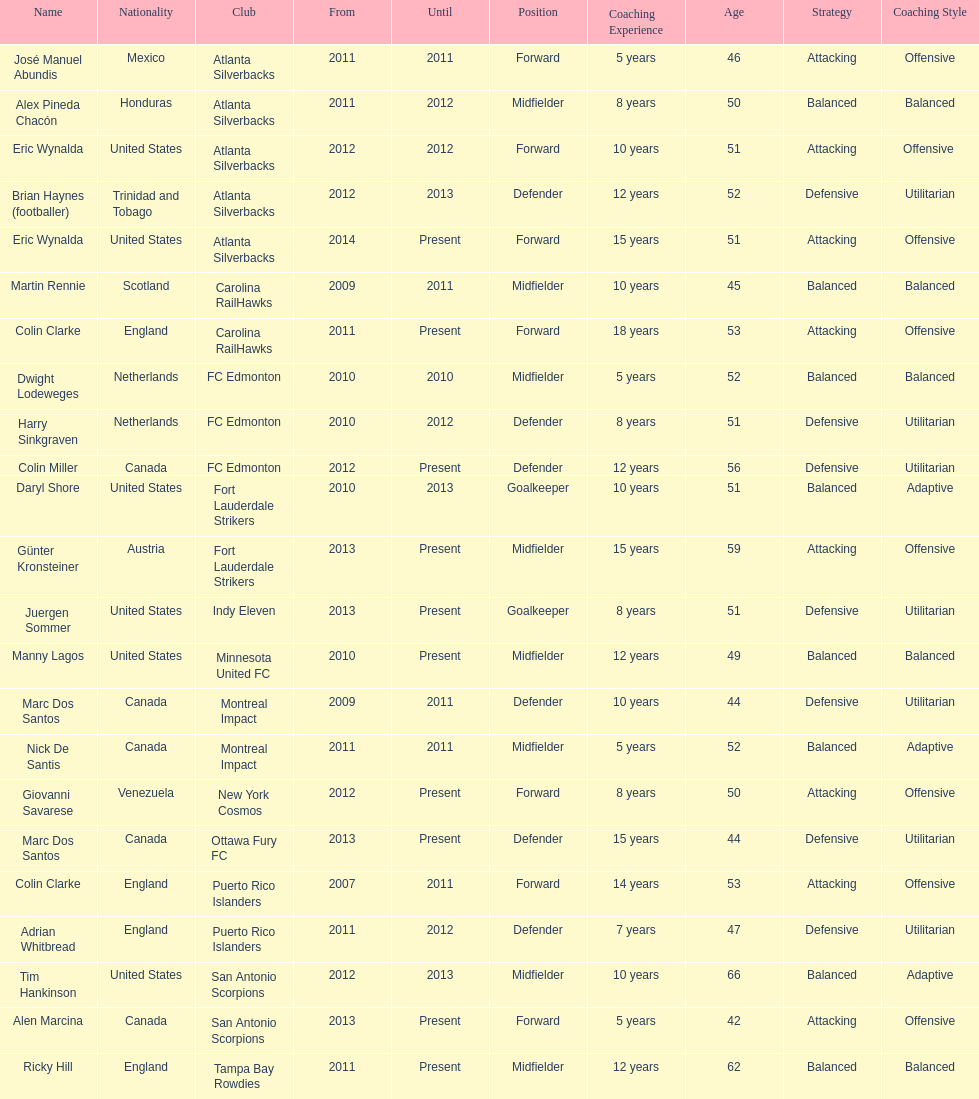Who was the coach of fc edmonton before miller? Harry Sinkgraven. 